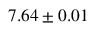Convert formula to latex. <formula><loc_0><loc_0><loc_500><loc_500>7 . 6 4 \pm 0 . 0 1</formula> 